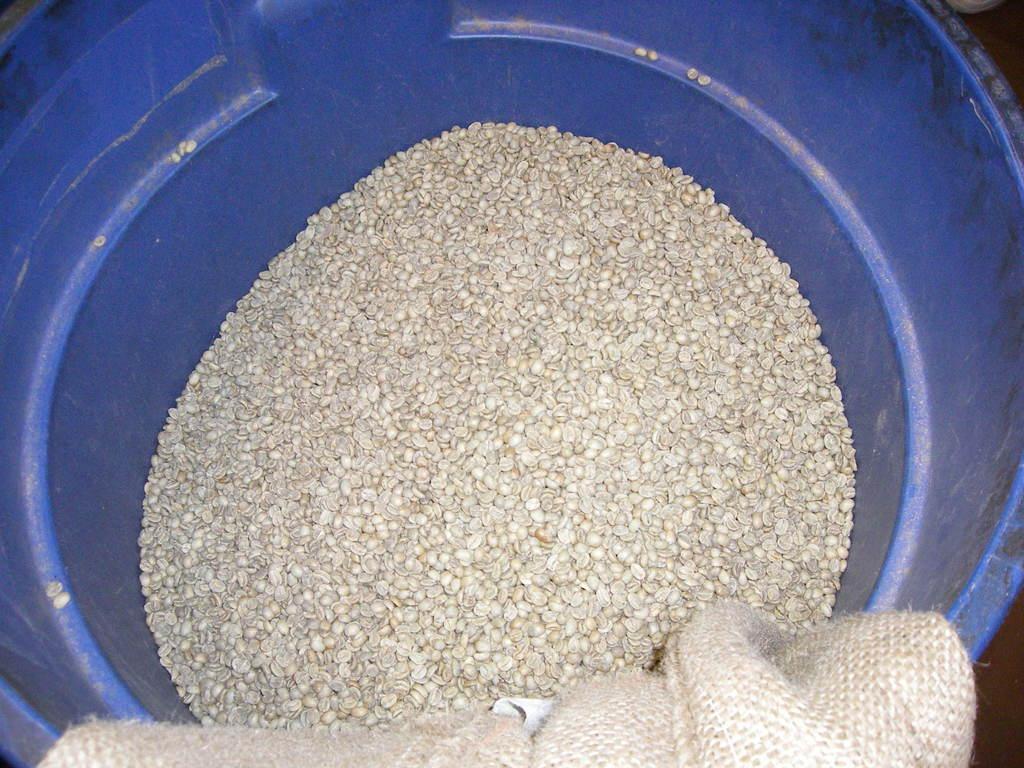In one or two sentences, can you explain what this image depicts? In this image there is a tub, and in the tub there are some tiny objects. And at the bottom of the image there is a bag. 